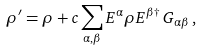Convert formula to latex. <formula><loc_0><loc_0><loc_500><loc_500>\rho ^ { \prime } = \rho + c \sum _ { \alpha , \beta } E ^ { \alpha } \rho E ^ { \beta \dagger } \, G _ { \alpha \beta } \, ,</formula> 